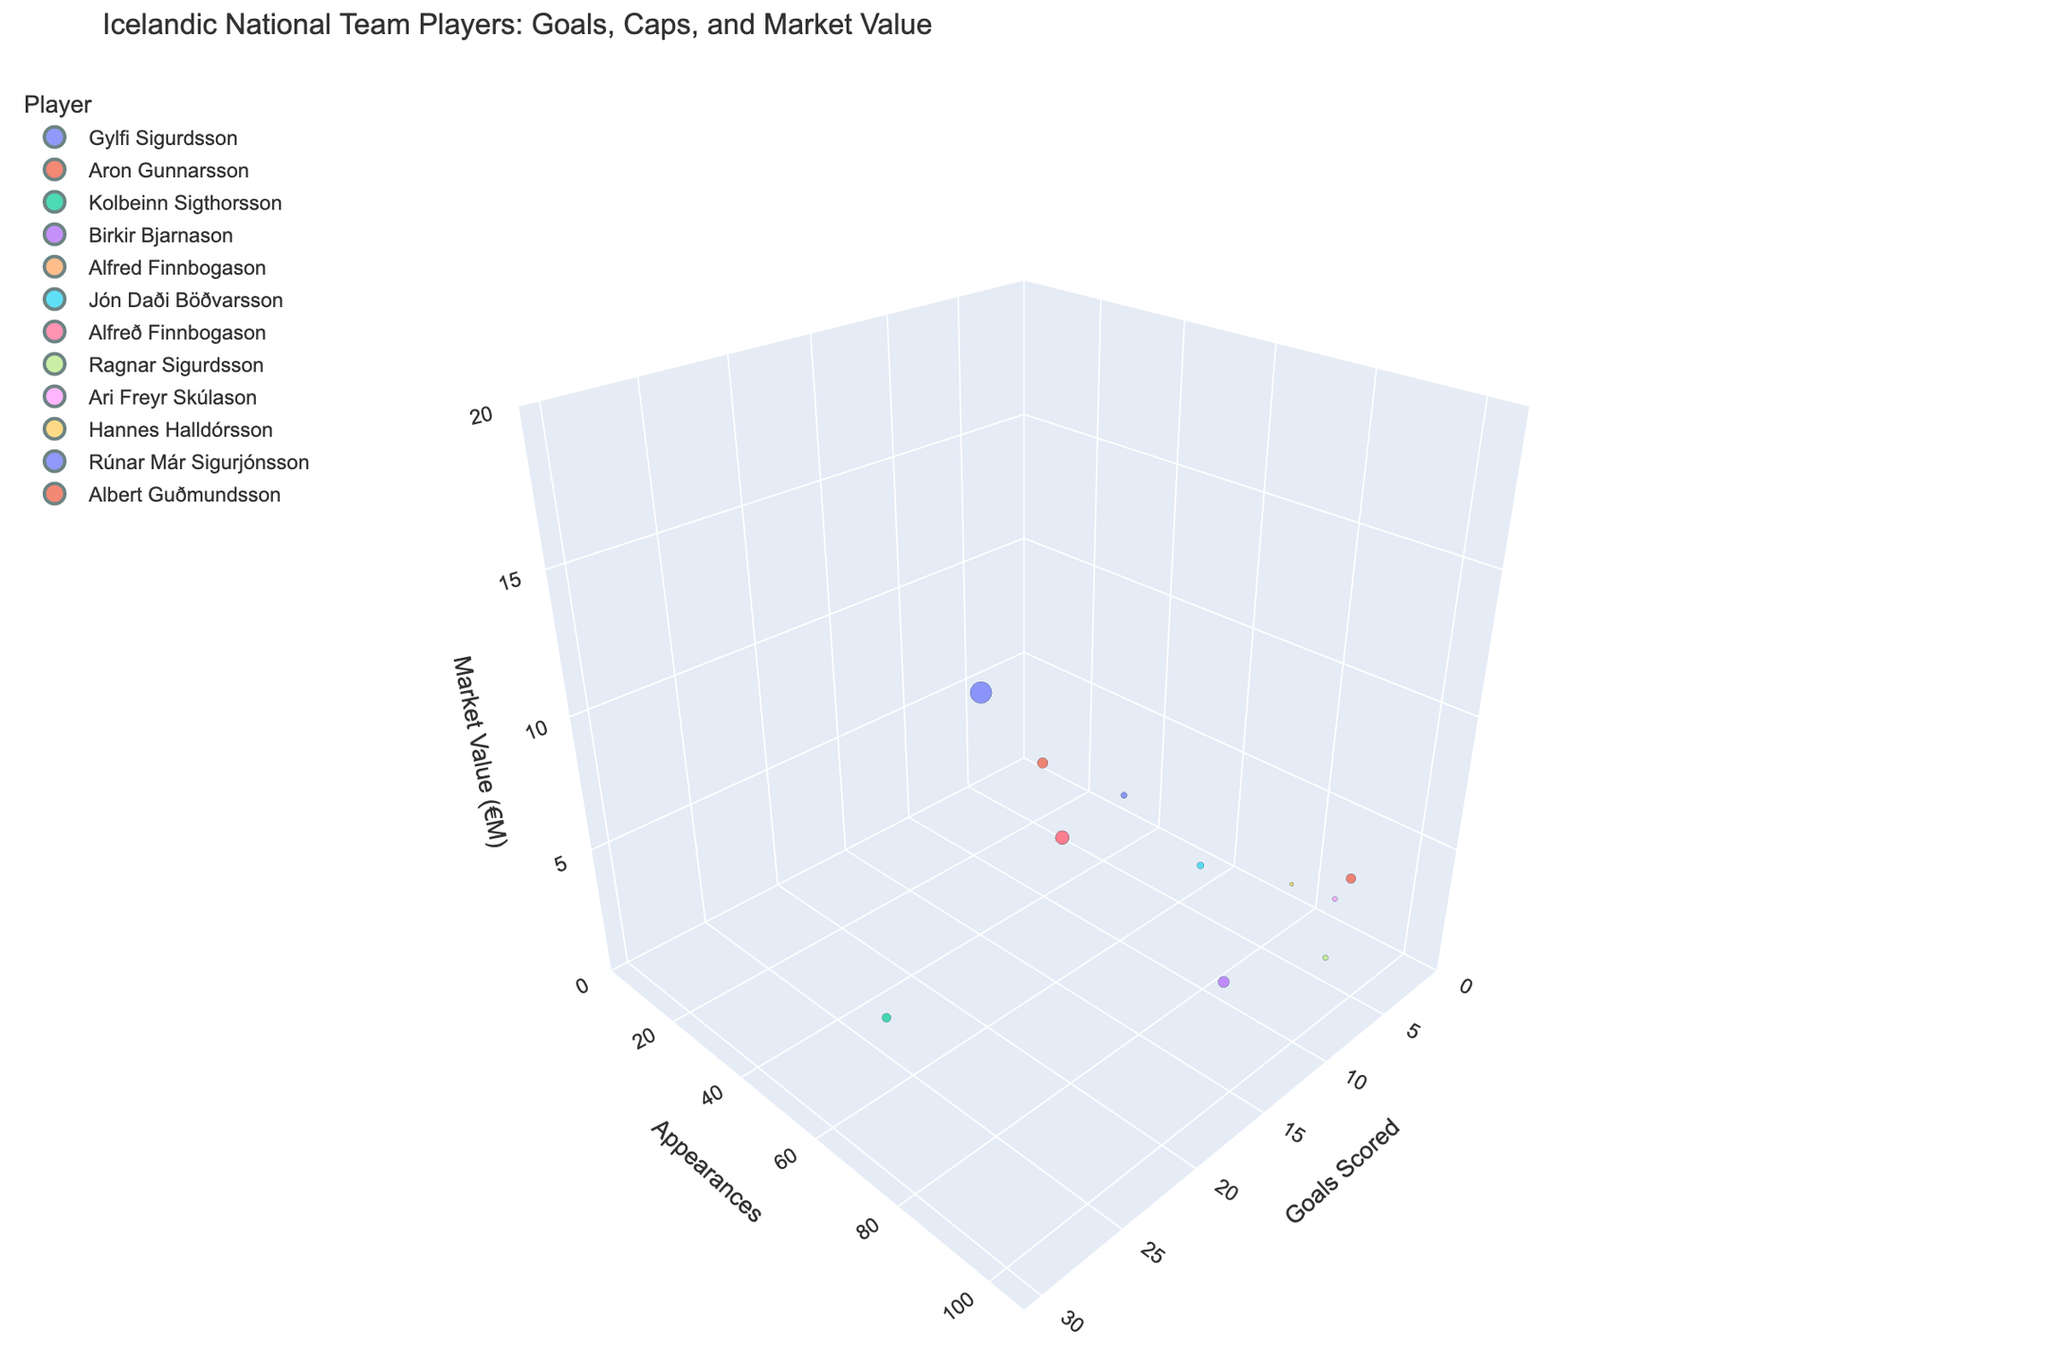How many players have a market value of more than 10 million euros? Identify all players' market values from the data and count those above 10 million euros. Only Gylfi Sigurdsson has a market value of 15 million euros, which is above 10 million euros.
Answer: 1 Which player has the highest number of caps? Identify the caps for each player from the chart and determine who has the maximum value. Birkir Bjarnason has the highest number of caps at 97.
Answer: Birkir Bjarnason Which player has the highest number of both goals and caps? Compare goals and caps for each player. Kolbeinn Sigthorsson has the highest goals at 26, while Birkir Bjarnason has the highest caps at 97. Since no single player has the highest in both categories, this question is a trick: Look at both attributes separately.
Answer: No single player Who has higher market value, Jón Daði Böðvarsson or Albert Guðmundsson? Compare the market values of Jón Daði Böðvarsson (1.5 million euros) and Albert Guðmundsson (3.5 million euros). Albert Guðmundsson's market value is higher.
Answer: Albert Guðmundsson What is the total market value for players with over 20 goals? Identify players with over 20 goals: Gylfi Sigurdsson (15 million euros) and Kolbeinn Sigthorsson (2.5 million euros). Sum their market values: 15 + 2.5 = 17.5 million euros.
Answer: 17.5 How many players have scored zero goals? Identify players with zero goals, which are Ari Freyr Skúlason and Hannes Halldórsson, and count them.
Answer: 2 Who are the top three players with the highest goals scored? Rank players by goals scored: Kolbeinn Sigthorsson (26), Gylfi Sigurdsson (25), Alfred Finnbogason and Birkir Bjarnason (tie at 15). The top three are Kolbeinn Sigthorsson, Gylfi Sigurdsson, and Alfred Finnbogason/Birkir Bjarnason (tie).
Answer: Kolbeinn Sigthorsson, Gylfi Sigurdsson, Alfred Finnbogason/Birkir Bjarnason What is the average market value of players with more than 50 caps? Identify players with more than 50 caps: Aron Gunnarsson, Gylfi Sigurdsson, Kolbeinn Sigthorsson, Birkir Bjarnason, Ragnar Sigurdsson, Jón Daði Böðvarsson, Ari Freyr Skúlason, Alfred Finnbogason. Sum their market values (3 + 15 + 2.5 + 4 + 1 + 1.5 + 0.8 + 6 = 33.8) and divide by their count (8). 33.8 / 8 = 4.225 million euros.
Answer: 4.225 Which player has the smallest bubble size, and what does it represent? The bubbles represent market value. The smallest bubble is for Hannes Halldórsson with a market value of 0.5 million euros.
Answer: Hannes Halldórsson, 0.5 million euros 